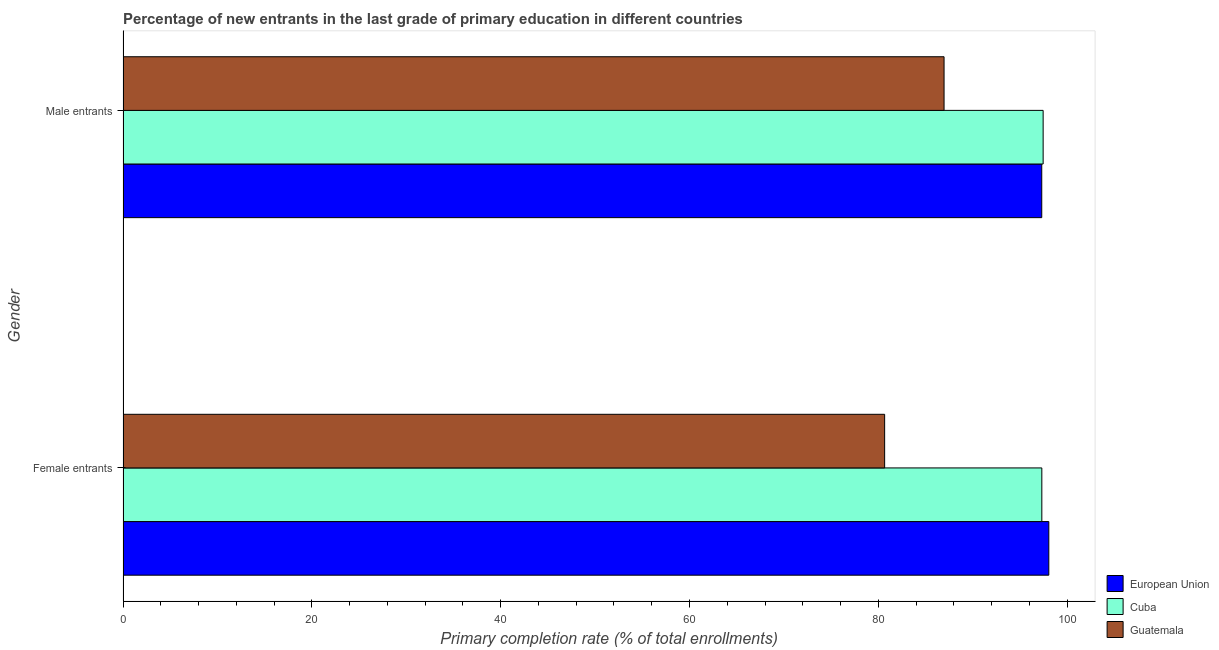Are the number of bars per tick equal to the number of legend labels?
Provide a short and direct response. Yes. How many bars are there on the 2nd tick from the top?
Give a very brief answer. 3. What is the label of the 1st group of bars from the top?
Offer a very short reply. Male entrants. What is the primary completion rate of male entrants in Guatemala?
Offer a terse response. 86.96. Across all countries, what is the maximum primary completion rate of male entrants?
Offer a very short reply. 97.45. Across all countries, what is the minimum primary completion rate of male entrants?
Your answer should be very brief. 86.96. In which country was the primary completion rate of male entrants maximum?
Offer a very short reply. Cuba. In which country was the primary completion rate of female entrants minimum?
Ensure brevity in your answer.  Guatemala. What is the total primary completion rate of male entrants in the graph?
Provide a succinct answer. 281.71. What is the difference between the primary completion rate of male entrants in European Union and that in Cuba?
Provide a short and direct response. -0.15. What is the difference between the primary completion rate of female entrants in Cuba and the primary completion rate of male entrants in European Union?
Offer a very short reply. 0.01. What is the average primary completion rate of female entrants per country?
Your answer should be compact. 92.01. What is the difference between the primary completion rate of female entrants and primary completion rate of male entrants in European Union?
Keep it short and to the point. 0.75. What is the ratio of the primary completion rate of male entrants in Guatemala to that in European Union?
Ensure brevity in your answer.  0.89. In how many countries, is the primary completion rate of male entrants greater than the average primary completion rate of male entrants taken over all countries?
Make the answer very short. 2. What does the 3rd bar from the bottom in Female entrants represents?
Provide a short and direct response. Guatemala. How many bars are there?
Keep it short and to the point. 6. Are all the bars in the graph horizontal?
Your answer should be very brief. Yes. Are the values on the major ticks of X-axis written in scientific E-notation?
Offer a terse response. No. How are the legend labels stacked?
Your answer should be very brief. Vertical. What is the title of the graph?
Provide a succinct answer. Percentage of new entrants in the last grade of primary education in different countries. What is the label or title of the X-axis?
Make the answer very short. Primary completion rate (% of total enrollments). What is the Primary completion rate (% of total enrollments) of European Union in Female entrants?
Make the answer very short. 98.05. What is the Primary completion rate (% of total enrollments) in Cuba in Female entrants?
Offer a terse response. 97.31. What is the Primary completion rate (% of total enrollments) in Guatemala in Female entrants?
Your answer should be compact. 80.66. What is the Primary completion rate (% of total enrollments) of European Union in Male entrants?
Provide a short and direct response. 97.3. What is the Primary completion rate (% of total enrollments) of Cuba in Male entrants?
Your answer should be compact. 97.45. What is the Primary completion rate (% of total enrollments) in Guatemala in Male entrants?
Ensure brevity in your answer.  86.96. Across all Gender, what is the maximum Primary completion rate (% of total enrollments) in European Union?
Your answer should be compact. 98.05. Across all Gender, what is the maximum Primary completion rate (% of total enrollments) of Cuba?
Your answer should be compact. 97.45. Across all Gender, what is the maximum Primary completion rate (% of total enrollments) in Guatemala?
Make the answer very short. 86.96. Across all Gender, what is the minimum Primary completion rate (% of total enrollments) in European Union?
Ensure brevity in your answer.  97.3. Across all Gender, what is the minimum Primary completion rate (% of total enrollments) of Cuba?
Your answer should be very brief. 97.31. Across all Gender, what is the minimum Primary completion rate (% of total enrollments) in Guatemala?
Your answer should be very brief. 80.66. What is the total Primary completion rate (% of total enrollments) in European Union in the graph?
Your answer should be very brief. 195.36. What is the total Primary completion rate (% of total enrollments) of Cuba in the graph?
Your response must be concise. 194.76. What is the total Primary completion rate (% of total enrollments) of Guatemala in the graph?
Give a very brief answer. 167.62. What is the difference between the Primary completion rate (% of total enrollments) in European Union in Female entrants and that in Male entrants?
Your response must be concise. 0.75. What is the difference between the Primary completion rate (% of total enrollments) of Cuba in Female entrants and that in Male entrants?
Ensure brevity in your answer.  -0.14. What is the difference between the Primary completion rate (% of total enrollments) in Guatemala in Female entrants and that in Male entrants?
Provide a succinct answer. -6.29. What is the difference between the Primary completion rate (% of total enrollments) in European Union in Female entrants and the Primary completion rate (% of total enrollments) in Cuba in Male entrants?
Give a very brief answer. 0.6. What is the difference between the Primary completion rate (% of total enrollments) in European Union in Female entrants and the Primary completion rate (% of total enrollments) in Guatemala in Male entrants?
Keep it short and to the point. 11.09. What is the difference between the Primary completion rate (% of total enrollments) of Cuba in Female entrants and the Primary completion rate (% of total enrollments) of Guatemala in Male entrants?
Give a very brief answer. 10.35. What is the average Primary completion rate (% of total enrollments) in European Union per Gender?
Make the answer very short. 97.68. What is the average Primary completion rate (% of total enrollments) of Cuba per Gender?
Your answer should be very brief. 97.38. What is the average Primary completion rate (% of total enrollments) of Guatemala per Gender?
Keep it short and to the point. 83.81. What is the difference between the Primary completion rate (% of total enrollments) in European Union and Primary completion rate (% of total enrollments) in Cuba in Female entrants?
Offer a terse response. 0.74. What is the difference between the Primary completion rate (% of total enrollments) in European Union and Primary completion rate (% of total enrollments) in Guatemala in Female entrants?
Make the answer very short. 17.39. What is the difference between the Primary completion rate (% of total enrollments) of Cuba and Primary completion rate (% of total enrollments) of Guatemala in Female entrants?
Provide a succinct answer. 16.65. What is the difference between the Primary completion rate (% of total enrollments) of European Union and Primary completion rate (% of total enrollments) of Cuba in Male entrants?
Provide a short and direct response. -0.15. What is the difference between the Primary completion rate (% of total enrollments) of European Union and Primary completion rate (% of total enrollments) of Guatemala in Male entrants?
Provide a short and direct response. 10.35. What is the difference between the Primary completion rate (% of total enrollments) of Cuba and Primary completion rate (% of total enrollments) of Guatemala in Male entrants?
Offer a terse response. 10.49. What is the ratio of the Primary completion rate (% of total enrollments) of European Union in Female entrants to that in Male entrants?
Provide a succinct answer. 1.01. What is the ratio of the Primary completion rate (% of total enrollments) of Cuba in Female entrants to that in Male entrants?
Your answer should be very brief. 1. What is the ratio of the Primary completion rate (% of total enrollments) in Guatemala in Female entrants to that in Male entrants?
Your answer should be very brief. 0.93. What is the difference between the highest and the second highest Primary completion rate (% of total enrollments) in European Union?
Offer a very short reply. 0.75. What is the difference between the highest and the second highest Primary completion rate (% of total enrollments) in Cuba?
Offer a very short reply. 0.14. What is the difference between the highest and the second highest Primary completion rate (% of total enrollments) of Guatemala?
Your response must be concise. 6.29. What is the difference between the highest and the lowest Primary completion rate (% of total enrollments) of European Union?
Give a very brief answer. 0.75. What is the difference between the highest and the lowest Primary completion rate (% of total enrollments) in Cuba?
Ensure brevity in your answer.  0.14. What is the difference between the highest and the lowest Primary completion rate (% of total enrollments) in Guatemala?
Offer a very short reply. 6.29. 